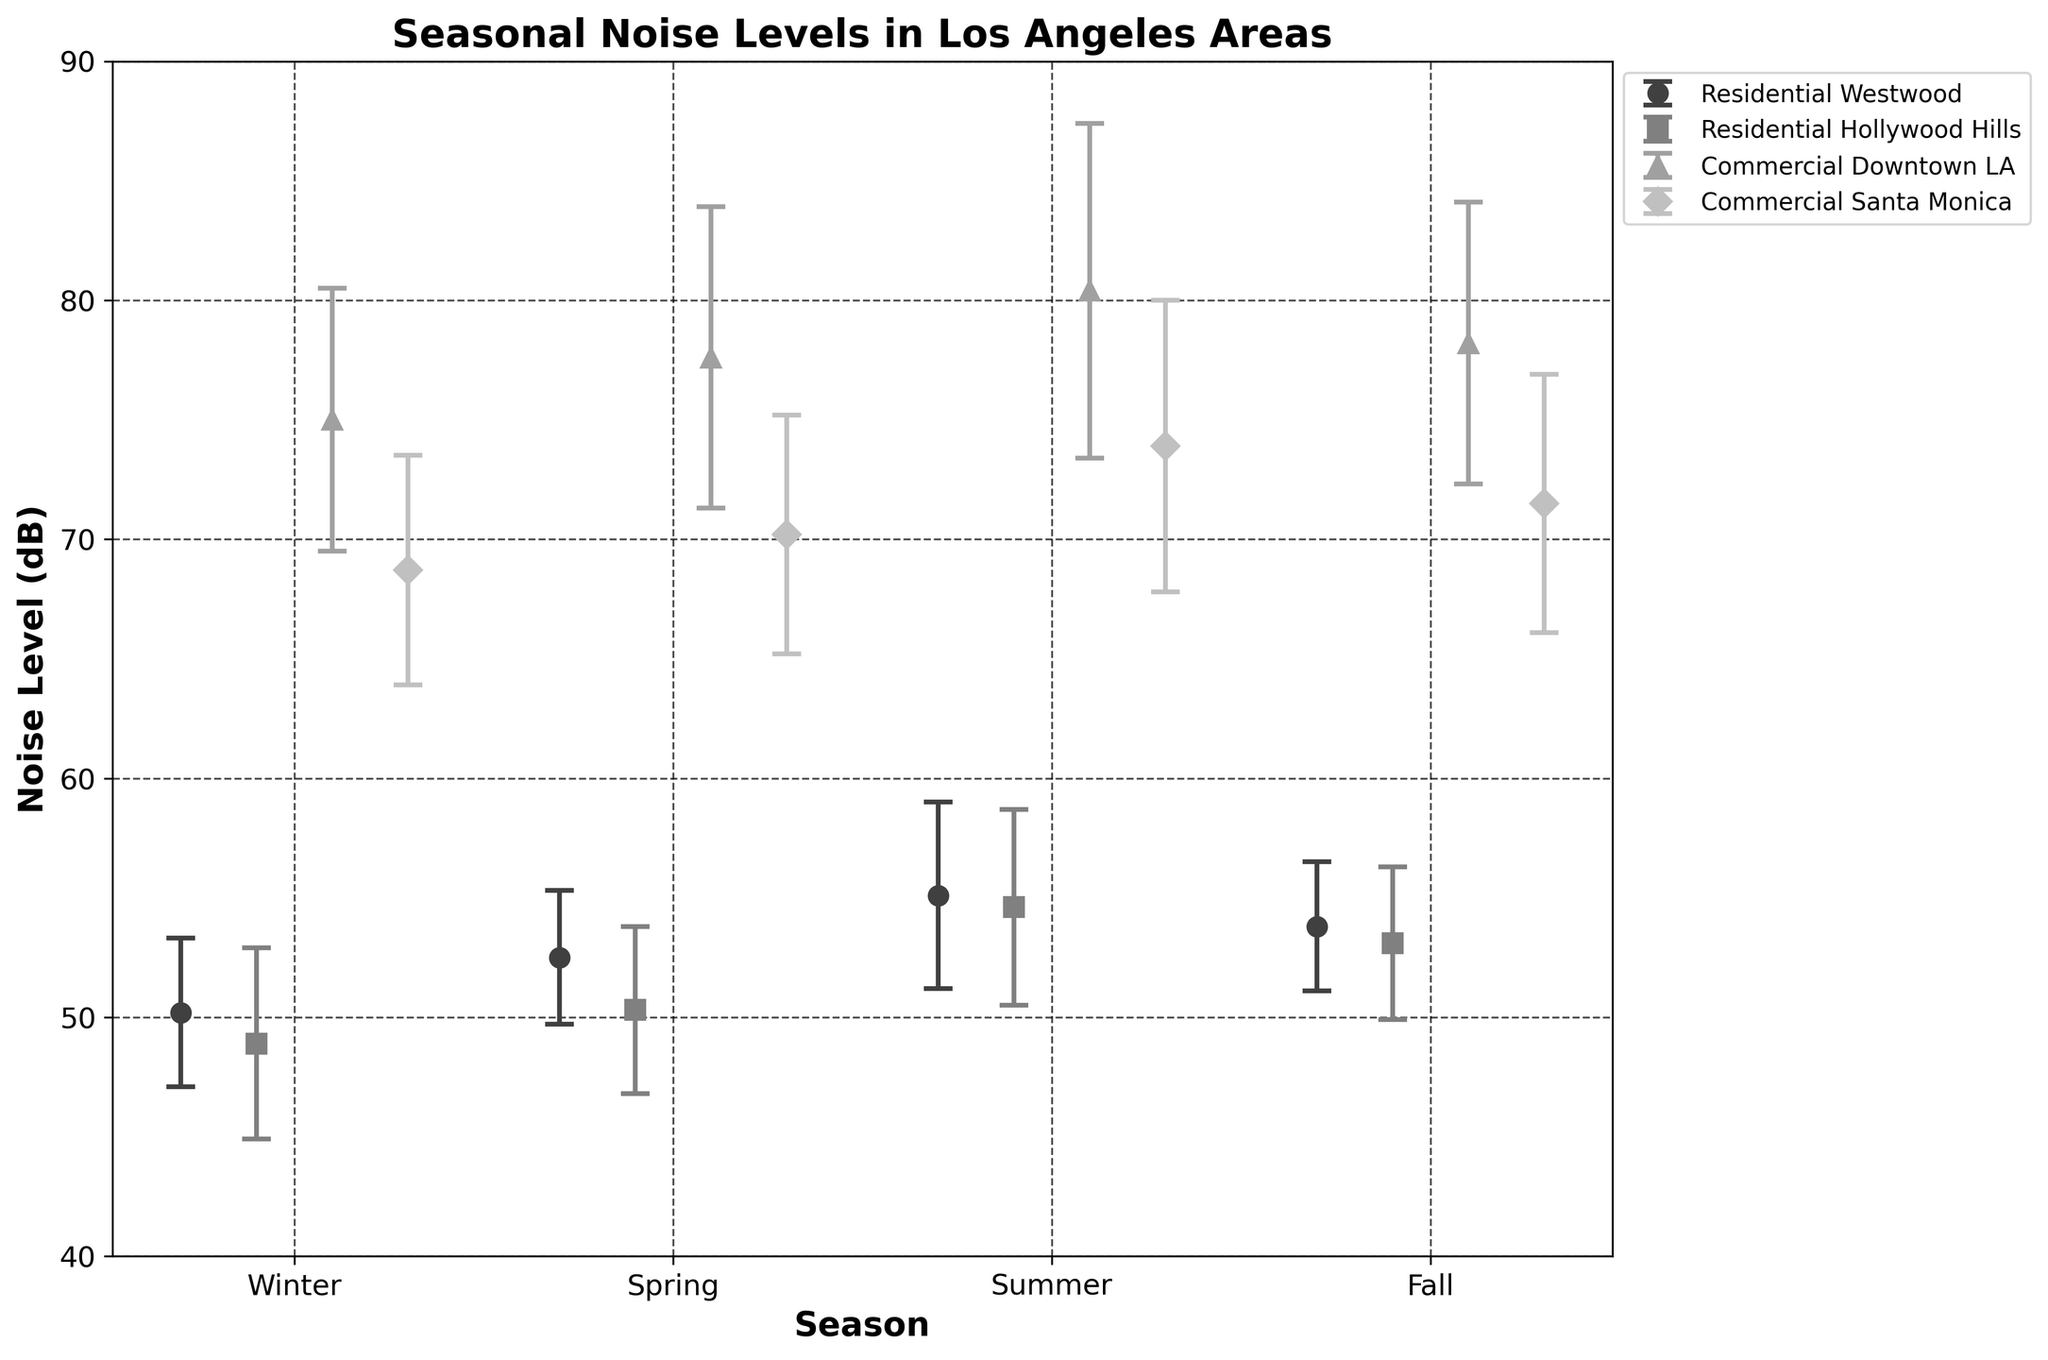What is the title of the plot? The title of the plot is typically found at the top of the figure and is used to describe the content of the plot.
Answer: Seasonal Noise Levels in Los Angeles Areas What is the noise level in Downtown LA during Summer? To find this, look for the data point representing Summer in the Downtown LA series.
Answer: 80.4 dB Which area has the highest noise level during Winter? Compare the winter data points for all areas to determine which one is the highest. Downtown LA's winter noise level is the highest.
Answer: Downtown LA What is the range of noise levels in Westwood across all seasons? Identify the minimum and maximum noise levels in the Westwood series, then calculate the range by subtracting the minimum from the maximum. The values are 50.2 dB (Winter) and 55.1 dB (Summer). The range is 55.1 - 50.2.
Answer: 4.9 dB In which season is the noise level lowest in Hollywood Hills? Look at the Hollywood Hills data for each season and identify the lowest value. The lowest value is in Winter.
Answer: Winter Compare the noise levels between Residential and Commercial areas in Summer. Which type of area is noisier on average? To answer this, compare the Summer noise levels of Residential (Westwood and Hollywood Hills) and Commercial (Downtown LA and Santa Monica) areas. Calculate the average noise level for each type by summing the noise levels for each area and dividing by the number of areas in each type. Residential: (55.1 + 54.6) / 2 = 54.85, Commercial: (80.4 + 73.9) / 2 = 77.15.
Answer: Commercial areas What is the average noise level in Santa Monica over all seasons? Sum the noise levels for all seasons in Santa Monica and divide by the number of seasons. The values are 68.7, 70.2, 73.9, and 71.5. The average is (68.7 + 70.2 + 73.9 + 71.5) / 4.
Answer: 71.1 dB How does the noise level variation (standard deviation) in Downtown LA compare to Santa Monica during Spring? Look at the standard deviations for Spring in both areas. Downtown LA has a standard deviation of 6.3 dB, while Santa Monica has 5.0 dB. Downtown LA's noise variation is higher.
Answer: Downtown LA Which area has the largest seasonal variation in noise levels? Compare the ranges (difference between maximum and minimum values) of noise levels for each area. Downtown LA has the highest seasonal variation with a range of 80.4 - 75.0.
Answer: Downtown LA 